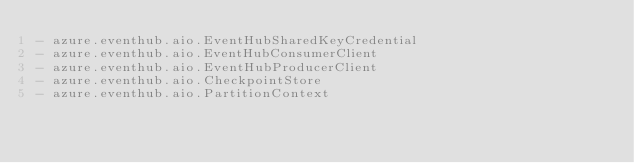<code> <loc_0><loc_0><loc_500><loc_500><_YAML_>- azure.eventhub.aio.EventHubSharedKeyCredential
- azure.eventhub.aio.EventHubConsumerClient
- azure.eventhub.aio.EventHubProducerClient
- azure.eventhub.aio.CheckpointStore
- azure.eventhub.aio.PartitionContext
</code> 